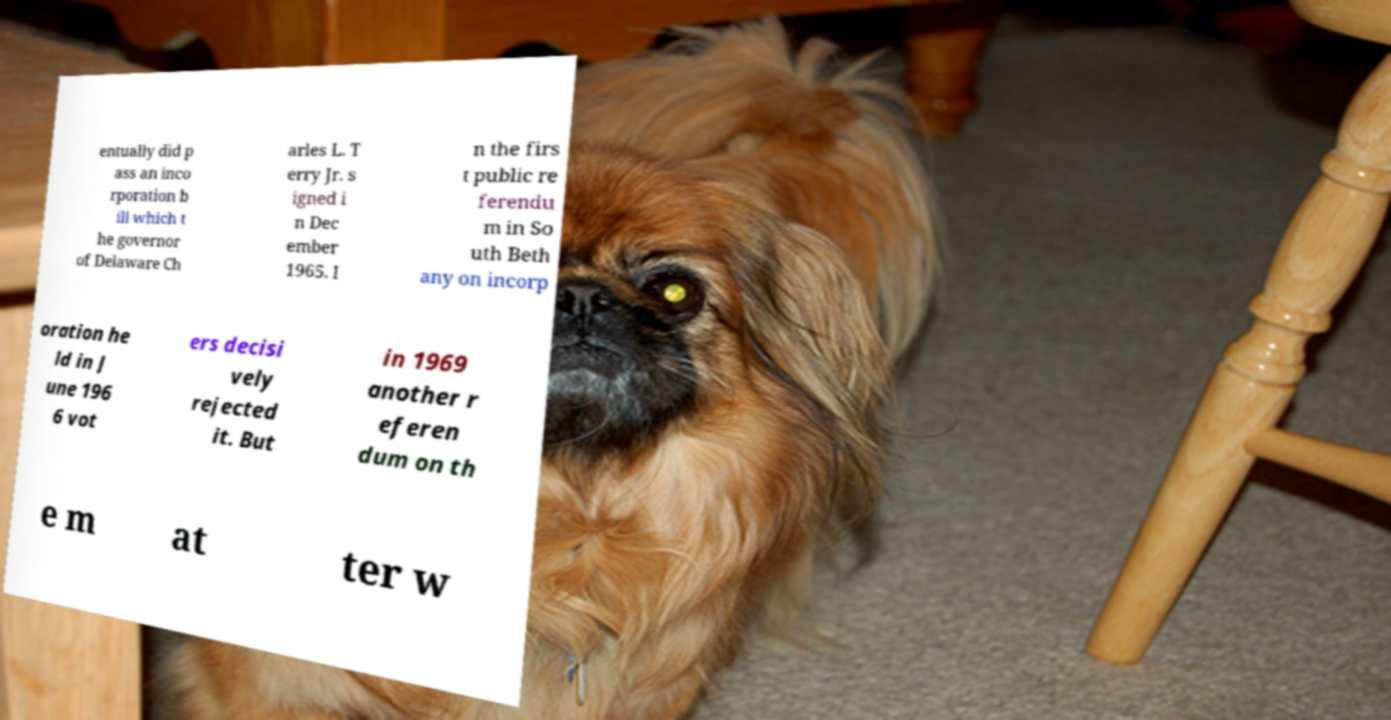Please read and relay the text visible in this image. What does it say? entually did p ass an inco rporation b ill which t he governor of Delaware Ch arles L. T erry Jr. s igned i n Dec ember 1965. I n the firs t public re ferendu m in So uth Beth any on incorp oration he ld in J une 196 6 vot ers decisi vely rejected it. But in 1969 another r eferen dum on th e m at ter w 